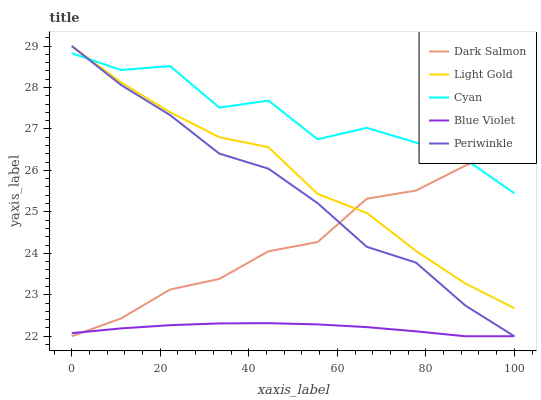Does Blue Violet have the minimum area under the curve?
Answer yes or no. Yes. Does Cyan have the maximum area under the curve?
Answer yes or no. Yes. Does Periwinkle have the minimum area under the curve?
Answer yes or no. No. Does Periwinkle have the maximum area under the curve?
Answer yes or no. No. Is Blue Violet the smoothest?
Answer yes or no. Yes. Is Cyan the roughest?
Answer yes or no. Yes. Is Periwinkle the smoothest?
Answer yes or no. No. Is Periwinkle the roughest?
Answer yes or no. No. Does Periwinkle have the lowest value?
Answer yes or no. Yes. Does Light Gold have the lowest value?
Answer yes or no. No. Does Light Gold have the highest value?
Answer yes or no. Yes. Does Dark Salmon have the highest value?
Answer yes or no. No. Is Blue Violet less than Cyan?
Answer yes or no. Yes. Is Light Gold greater than Blue Violet?
Answer yes or no. Yes. Does Periwinkle intersect Cyan?
Answer yes or no. Yes. Is Periwinkle less than Cyan?
Answer yes or no. No. Is Periwinkle greater than Cyan?
Answer yes or no. No. Does Blue Violet intersect Cyan?
Answer yes or no. No. 